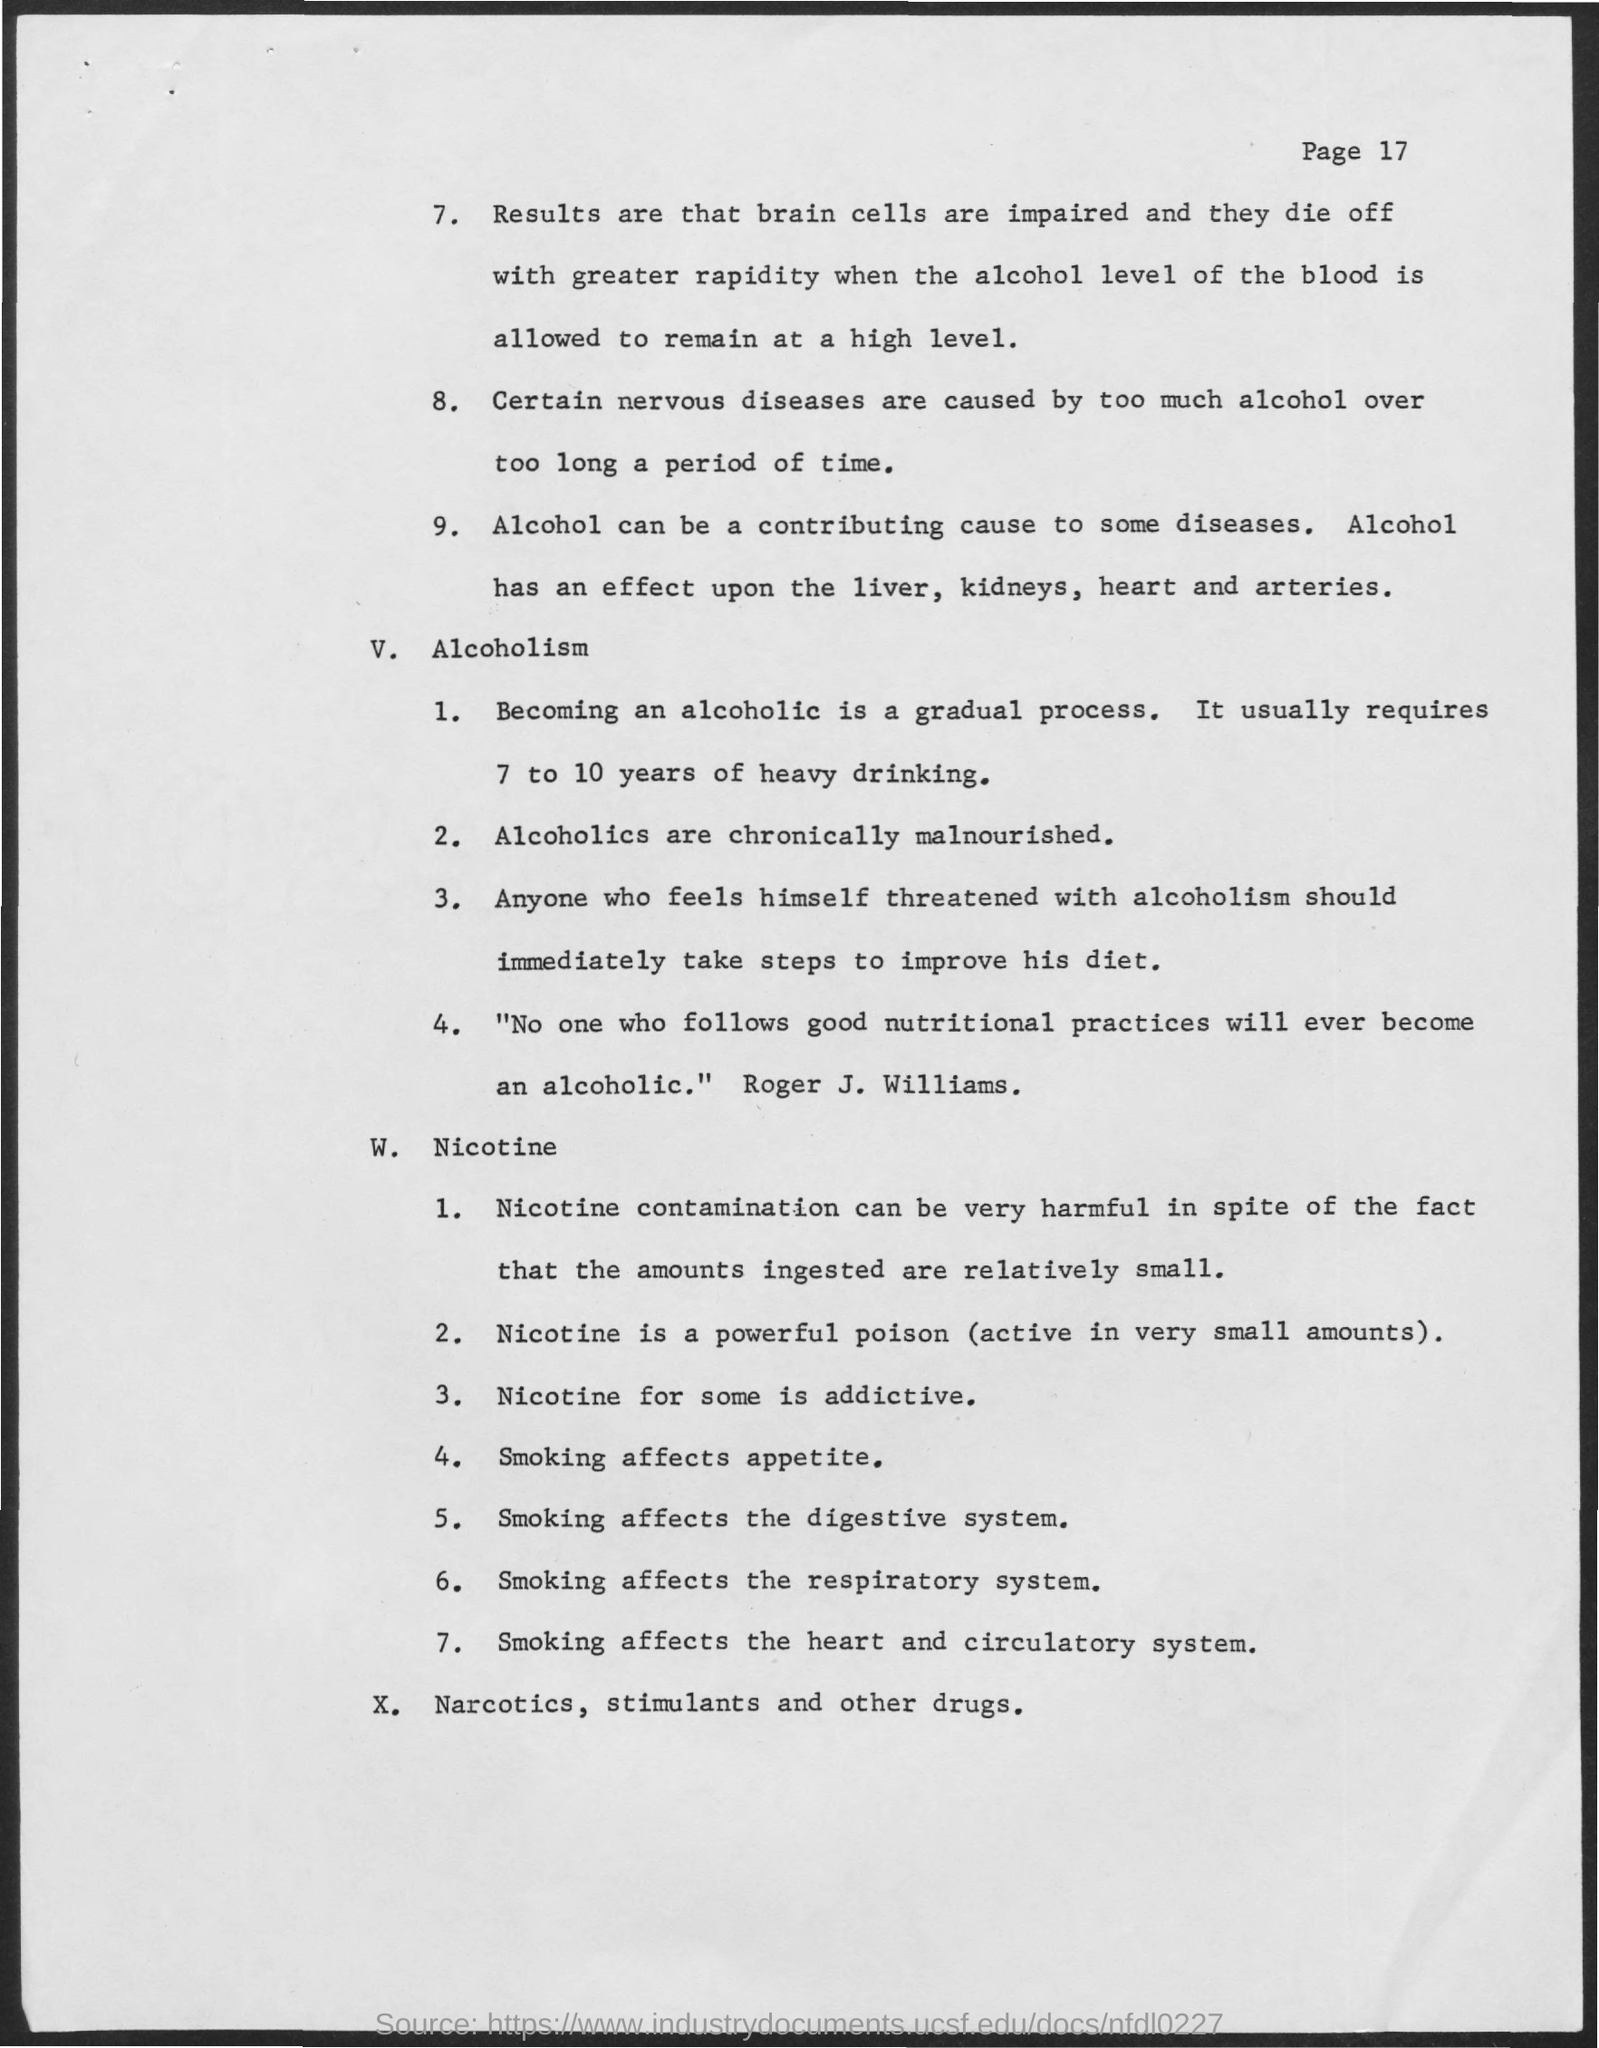Highlight a few significant elements in this photo. It takes approximately 7 to 10 years of continuous heavy drinking for someone to become an alcoholic. The current page is page 17, as indicated by the label 'Page No.' 